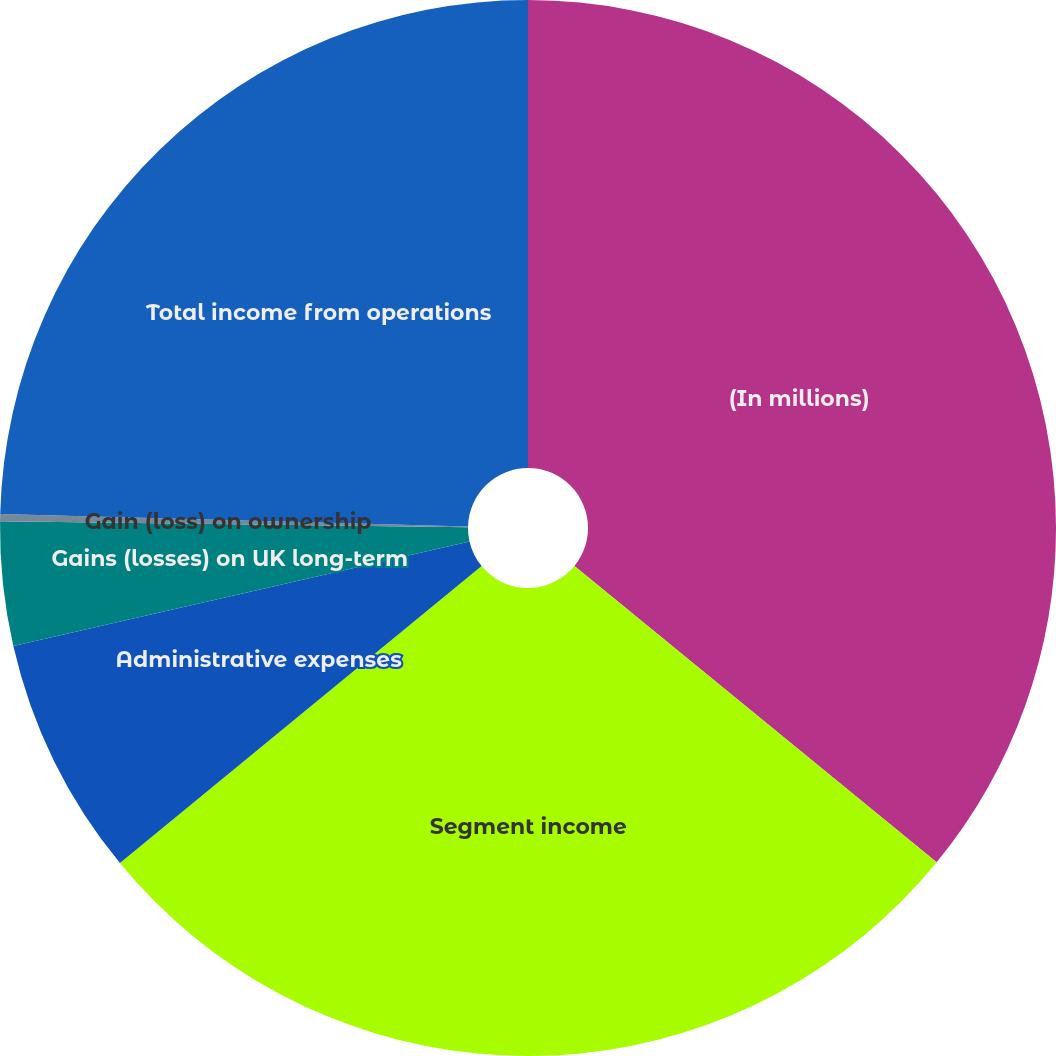Convert chart. <chart><loc_0><loc_0><loc_500><loc_500><pie_chart><fcel>(In millions)<fcel>Segment income<fcel>Administrative expenses<fcel>Gains (losses) on UK long-term<fcel>Gain (loss) on ownership<fcel>Total income from operations<nl><fcel>35.92%<fcel>28.15%<fcel>7.36%<fcel>3.79%<fcel>0.22%<fcel>24.58%<nl></chart> 